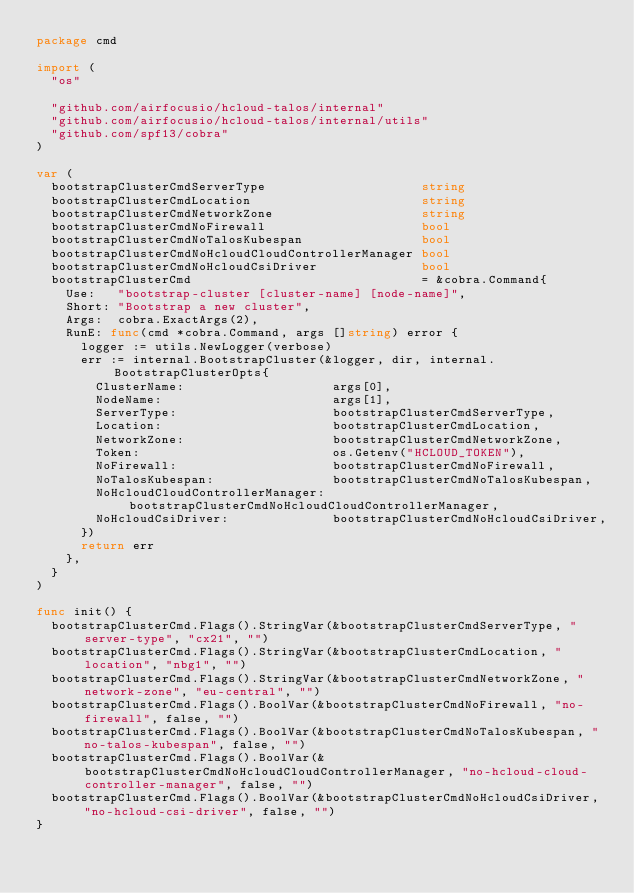<code> <loc_0><loc_0><loc_500><loc_500><_Go_>package cmd

import (
	"os"

	"github.com/airfocusio/hcloud-talos/internal"
	"github.com/airfocusio/hcloud-talos/internal/utils"
	"github.com/spf13/cobra"
)

var (
	bootstrapClusterCmdServerType                     string
	bootstrapClusterCmdLocation                       string
	bootstrapClusterCmdNetworkZone                    string
	bootstrapClusterCmdNoFirewall                     bool
	bootstrapClusterCmdNoTalosKubespan                bool
	bootstrapClusterCmdNoHcloudCloudControllerManager bool
	bootstrapClusterCmdNoHcloudCsiDriver              bool
	bootstrapClusterCmd                               = &cobra.Command{
		Use:   "bootstrap-cluster [cluster-name] [node-name]",
		Short: "Bootstrap a new cluster",
		Args:  cobra.ExactArgs(2),
		RunE: func(cmd *cobra.Command, args []string) error {
			logger := utils.NewLogger(verbose)
			err := internal.BootstrapCluster(&logger, dir, internal.BootstrapClusterOpts{
				ClusterName:                    args[0],
				NodeName:                       args[1],
				ServerType:                     bootstrapClusterCmdServerType,
				Location:                       bootstrapClusterCmdLocation,
				NetworkZone:                    bootstrapClusterCmdNetworkZone,
				Token:                          os.Getenv("HCLOUD_TOKEN"),
				NoFirewall:                     bootstrapClusterCmdNoFirewall,
				NoTalosKubespan:                bootstrapClusterCmdNoTalosKubespan,
				NoHcloudCloudControllerManager: bootstrapClusterCmdNoHcloudCloudControllerManager,
				NoHcloudCsiDriver:              bootstrapClusterCmdNoHcloudCsiDriver,
			})
			return err
		},
	}
)

func init() {
	bootstrapClusterCmd.Flags().StringVar(&bootstrapClusterCmdServerType, "server-type", "cx21", "")
	bootstrapClusterCmd.Flags().StringVar(&bootstrapClusterCmdLocation, "location", "nbg1", "")
	bootstrapClusterCmd.Flags().StringVar(&bootstrapClusterCmdNetworkZone, "network-zone", "eu-central", "")
	bootstrapClusterCmd.Flags().BoolVar(&bootstrapClusterCmdNoFirewall, "no-firewall", false, "")
	bootstrapClusterCmd.Flags().BoolVar(&bootstrapClusterCmdNoTalosKubespan, "no-talos-kubespan", false, "")
	bootstrapClusterCmd.Flags().BoolVar(&bootstrapClusterCmdNoHcloudCloudControllerManager, "no-hcloud-cloud-controller-manager", false, "")
	bootstrapClusterCmd.Flags().BoolVar(&bootstrapClusterCmdNoHcloudCsiDriver, "no-hcloud-csi-driver", false, "")
}
</code> 